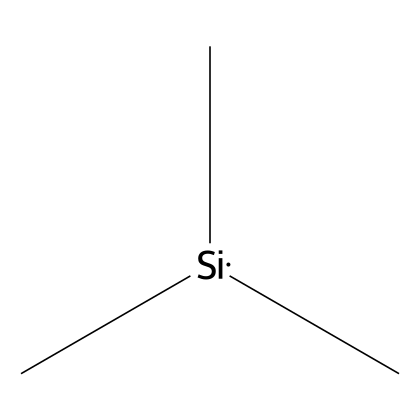What is the name of the chemical represented by this structure? The SMILES representation "C[Si](C)C" indicates that the chemical is trimethylsilane, which is indeed corroborated by its structural formula comprising three methyl groups bound to a silicon atom.
Answer: trimethylsilane How many silicon atoms are present in this chemical? The molecular structure features a single silicon atom, which is directly connected to three methyl groups according to the SMILES notation.
Answer: one What is the total number of hydrogen atoms in this molecule? Each methyl group (CH3) contributes three hydrogen atoms, and with three methyl groups connected to the silicon atom, we calculate 3 groups x 3 hydrogen = 9.
Answer: nine Is this chemical organic or inorganic? Since trimethylsilane contains carbon, which classifies it under organic compounds, it can be identified as an organic silicon compound.
Answer: organic What type of chemical bonds are present in this structure? The bonds between the silicon atom and the three methyl groups are single covalent bonds, which connect the carbon atoms of the methyl groups to silicon.
Answer: single covalent Why is trimethylsilane used in water treatment policies? Trimethylsilane can be used to modify the surface properties of materials or to introduce hydrophobic properties in water treatment processes, which is essential for enhancing certain procedures.
Answer: surface modification How many carbon atoms are in the structure? The representation shows three methyl groups, each containing one carbon atom, culminating in a total of three carbon atoms.
Answer: three 